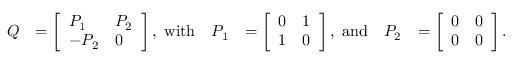Convert formula to latex. <formula><loc_0><loc_0><loc_500><loc_500>\begin{array} { r l r l r l } { Q } & { = \left [ \begin{array} { l l } { P _ { 1 } } & { P _ { 2 } } \\ { - P _ { 2 } } & { 0 } \end{array} \right ] , w i t h } & { P _ { 1 } } & { = \left [ \begin{array} { l l } { 0 } & { 1 } \\ { 1 } & { 0 } \end{array} \right ] , a n d } & { P _ { 2 } } & { = \left [ \begin{array} { l l } { 0 } & { 0 } \\ { 0 } & { 0 } \end{array} \right ] . } \end{array}</formula> 